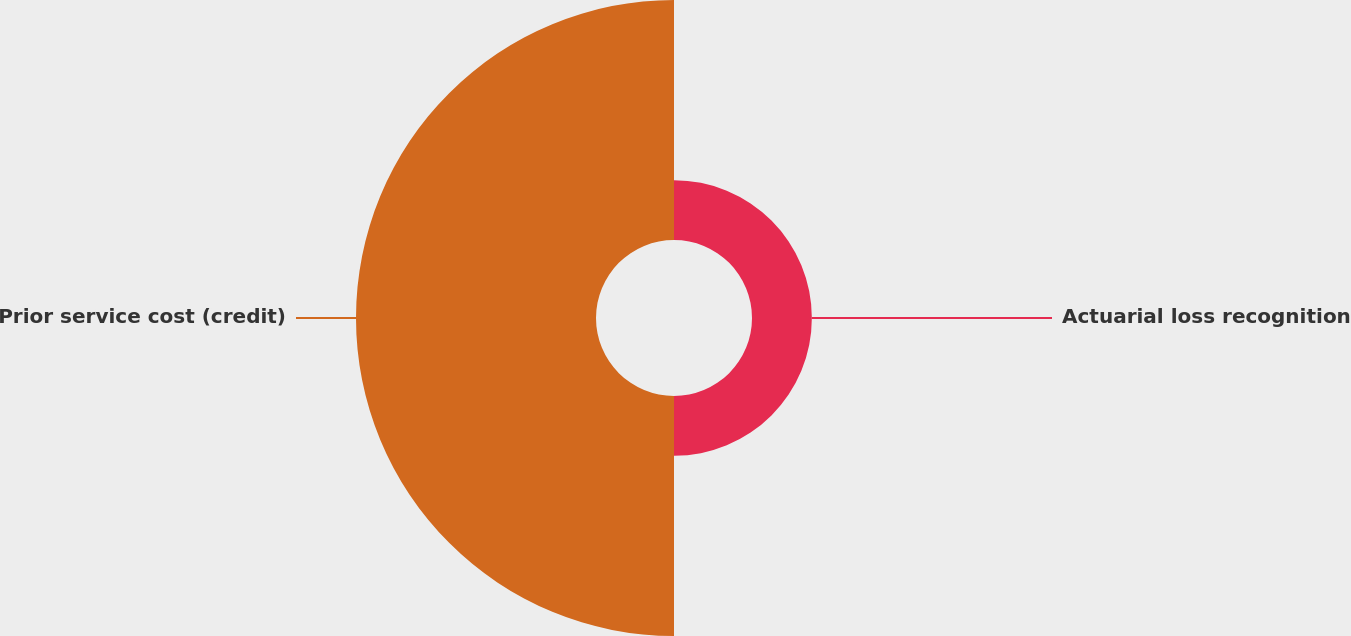<chart> <loc_0><loc_0><loc_500><loc_500><pie_chart><fcel>Actuarial loss recognition<fcel>Prior service cost (credit)<nl><fcel>19.96%<fcel>80.04%<nl></chart> 